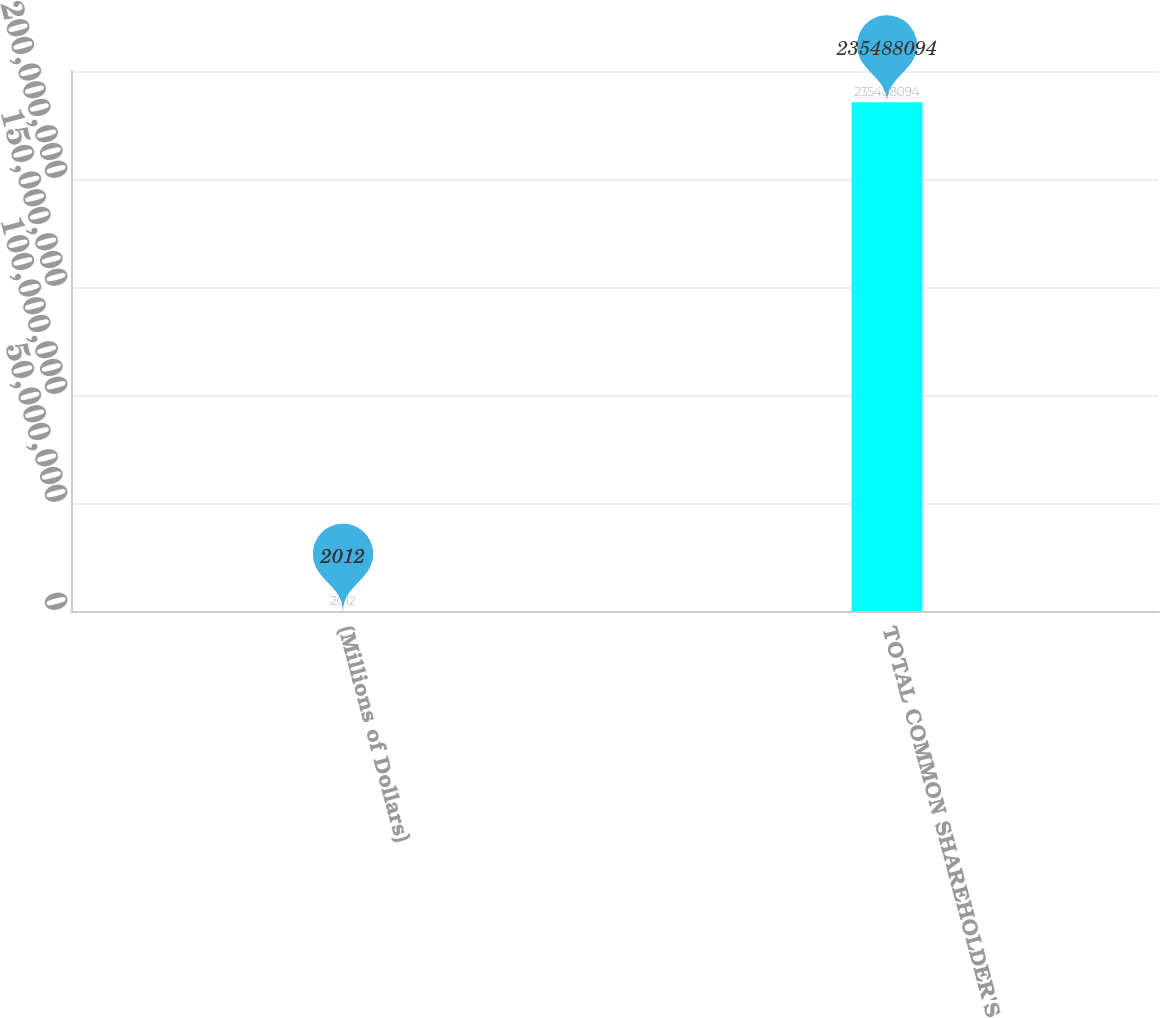Convert chart to OTSL. <chart><loc_0><loc_0><loc_500><loc_500><bar_chart><fcel>(Millions of Dollars)<fcel>TOTAL COMMON SHAREHOLDER'S<nl><fcel>2012<fcel>2.35488e+08<nl></chart> 